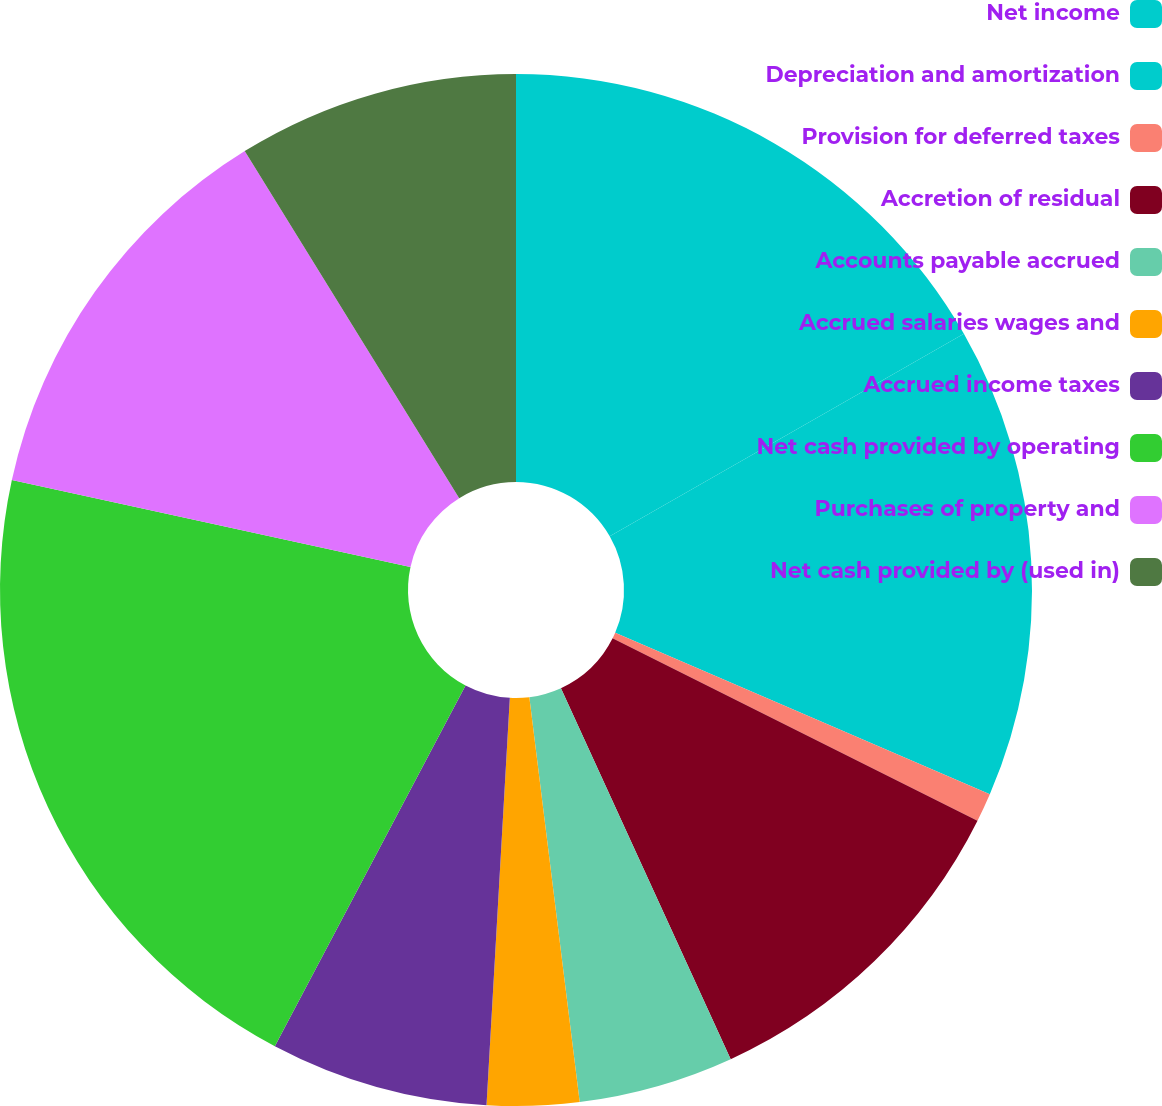Convert chart. <chart><loc_0><loc_0><loc_500><loc_500><pie_chart><fcel>Net income<fcel>Depreciation and amortization<fcel>Provision for deferred taxes<fcel>Accretion of residual<fcel>Accounts payable accrued<fcel>Accrued salaries wages and<fcel>Accrued income taxes<fcel>Net cash provided by operating<fcel>Purchases of property and<fcel>Net cash provided by (used in)<nl><fcel>16.73%<fcel>14.75%<fcel>0.9%<fcel>10.79%<fcel>4.86%<fcel>2.88%<fcel>6.83%<fcel>20.68%<fcel>12.77%<fcel>8.81%<nl></chart> 